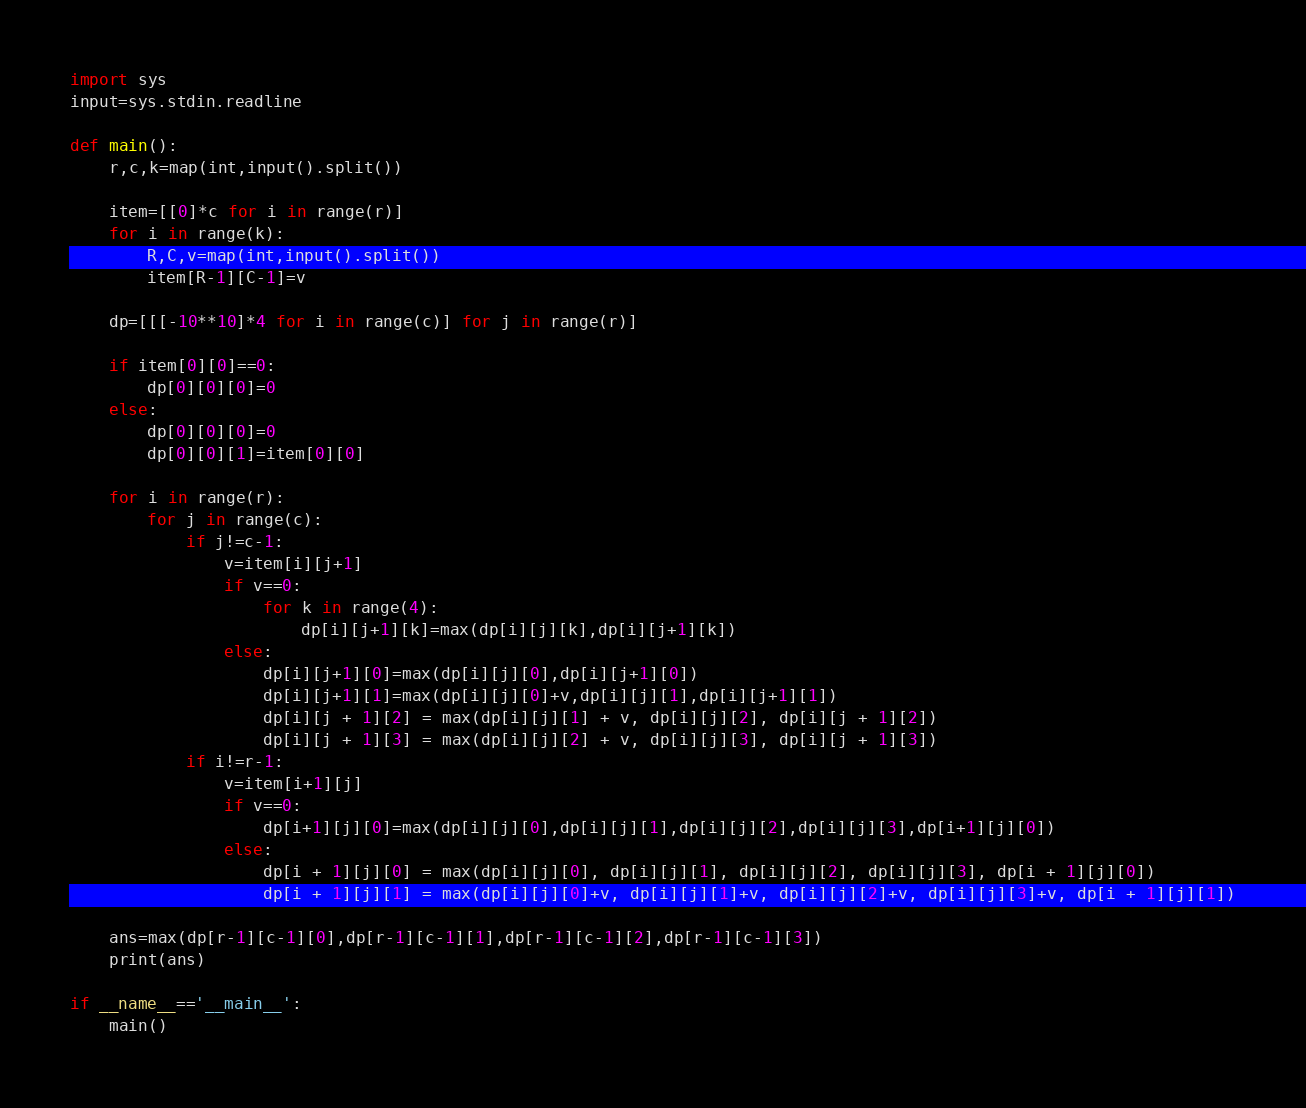<code> <loc_0><loc_0><loc_500><loc_500><_Python_>import sys
input=sys.stdin.readline

def main():
    r,c,k=map(int,input().split())

    item=[[0]*c for i in range(r)]
    for i in range(k):
        R,C,v=map(int,input().split())
        item[R-1][C-1]=v

    dp=[[[-10**10]*4 for i in range(c)] for j in range(r)]

    if item[0][0]==0:
        dp[0][0][0]=0
    else:
        dp[0][0][0]=0
        dp[0][0][1]=item[0][0]

    for i in range(r):
        for j in range(c):
            if j!=c-1:
                v=item[i][j+1]
                if v==0:
                    for k in range(4):
                        dp[i][j+1][k]=max(dp[i][j][k],dp[i][j+1][k])
                else:
                    dp[i][j+1][0]=max(dp[i][j][0],dp[i][j+1][0])
                    dp[i][j+1][1]=max(dp[i][j][0]+v,dp[i][j][1],dp[i][j+1][1])
                    dp[i][j + 1][2] = max(dp[i][j][1] + v, dp[i][j][2], dp[i][j + 1][2])
                    dp[i][j + 1][3] = max(dp[i][j][2] + v, dp[i][j][3], dp[i][j + 1][3])
            if i!=r-1:
                v=item[i+1][j]
                if v==0:
                    dp[i+1][j][0]=max(dp[i][j][0],dp[i][j][1],dp[i][j][2],dp[i][j][3],dp[i+1][j][0])
                else:
                    dp[i + 1][j][0] = max(dp[i][j][0], dp[i][j][1], dp[i][j][2], dp[i][j][3], dp[i + 1][j][0])
                    dp[i + 1][j][1] = max(dp[i][j][0]+v, dp[i][j][1]+v, dp[i][j][2]+v, dp[i][j][3]+v, dp[i + 1][j][1])

    ans=max(dp[r-1][c-1][0],dp[r-1][c-1][1],dp[r-1][c-1][2],dp[r-1][c-1][3])
    print(ans)

if __name__=='__main__':
    main()</code> 